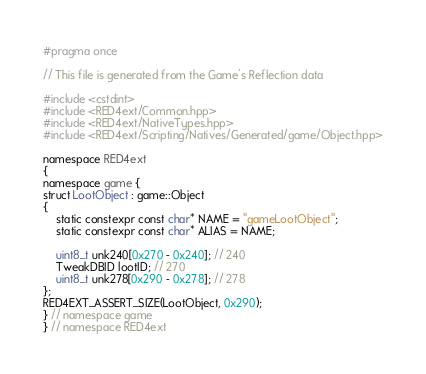<code> <loc_0><loc_0><loc_500><loc_500><_C++_>#pragma once

// This file is generated from the Game's Reflection data

#include <cstdint>
#include <RED4ext/Common.hpp>
#include <RED4ext/NativeTypes.hpp>
#include <RED4ext/Scripting/Natives/Generated/game/Object.hpp>

namespace RED4ext
{
namespace game { 
struct LootObject : game::Object
{
    static constexpr const char* NAME = "gameLootObject";
    static constexpr const char* ALIAS = NAME;

    uint8_t unk240[0x270 - 0x240]; // 240
    TweakDBID lootID; // 270
    uint8_t unk278[0x290 - 0x278]; // 278
};
RED4EXT_ASSERT_SIZE(LootObject, 0x290);
} // namespace game
} // namespace RED4ext
</code> 